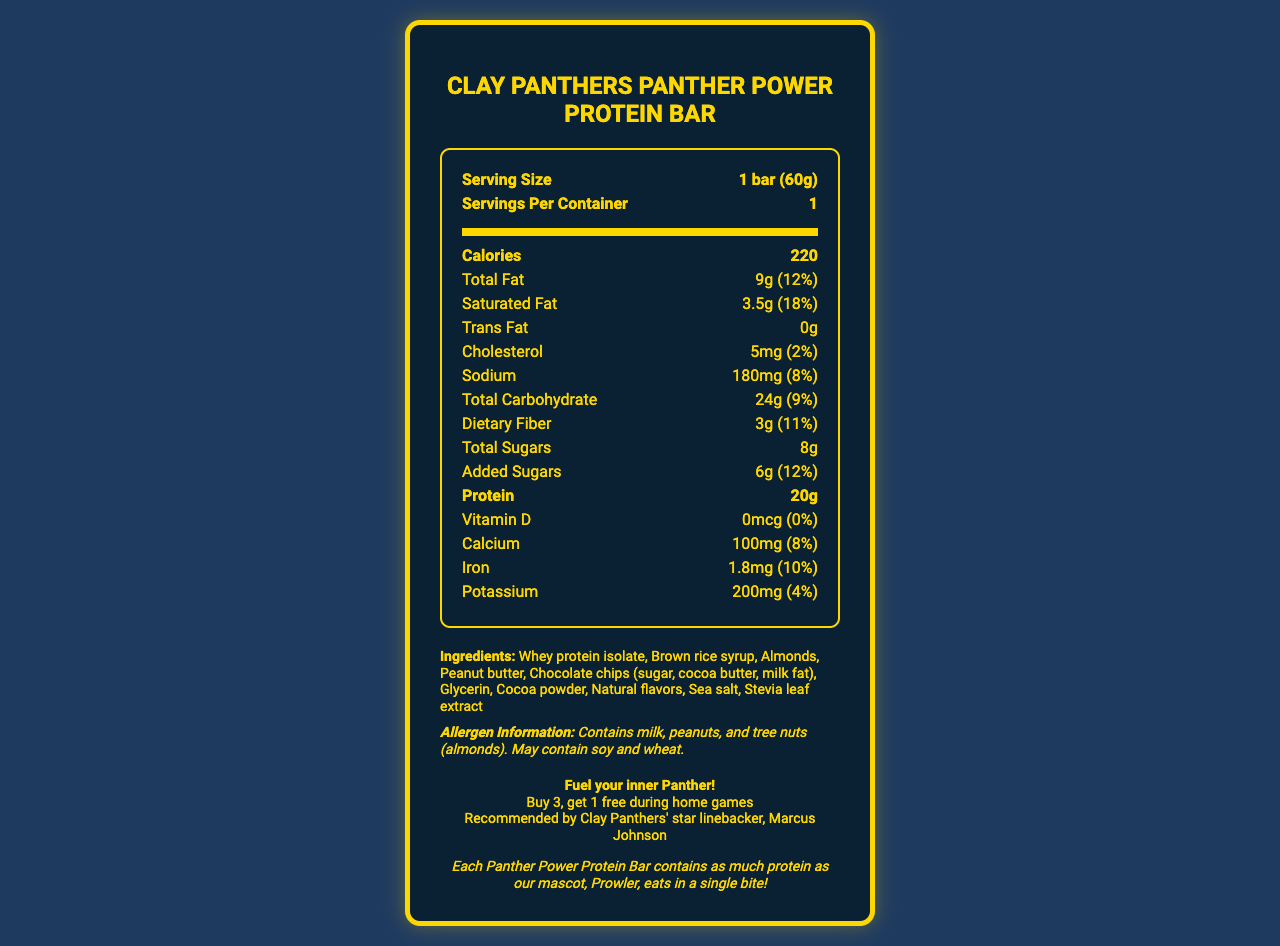what is the serving size of the Clay Panthers Panther Power Protein Bar? The serving size is clearly listed as "1 bar (60g)" in the document.
Answer: 1 bar (60g) how many calories are in one serving of the protein bar? The document lists the calories per serving as 220.
Answer: 220 how much total fat does the protein bar contain? The total fat content is written as "9g," which is also 12% of the daily value.
Answer: 9g how much protein is in each bar? Each bar contains 20 grams of protein according to the nutrition facts.
Answer: 20g how much calcium is in the Clay Panthers Panther Power Protein Bar? The document lists 100mg of calcium, which is 8% of the daily value.
Answer: 100mg what percentage of the daily value of saturated fat does the protein bar provide? The document specifies that the saturated fat content is 3.5g, which is 18% of the daily value.
Answer: 18% how many grams of total sugars are present in the protein bar? The document states that there are 8 grams of total sugars in the protein bar.
Answer: 8g what allergens are contained in the protein bar? The allergen information section specifies these allergens clearly.
Answer: Contains milk, peanuts, and tree nuts (almonds). May contain soy and wheat. which Clay Panthers player endorses the protein bar? A. Alex Smith B. Marcus Johnson C. David Brown The document states that the bar is recommended by Marcus Johnson, the star linebacker.
Answer: B what is the game day special offer mentioned in the document? A. Buy 2, get 1 free B. Buy 3, get 1 free C. 50% off on home games The game day special is listed as "Buy 3, get 1 free during home games."
Answer: B is the protein bar packaging sustainable? The document mentions that the wrapper is made from 100% recycled materials.
Answer: Yes summarize the main features of the Clay Panthers Panther Power Protein Bar as presented in the document. The summary condenses the main features such as nutrition details, endorsements, special offers, packaging sustainability, and allergen information mentioned in the document.
Answer: The Clay Panthers Panther Power Protein Bar is a stadium-exclusive product, endorsed by Marcus Johnson, and features 20 grams of protein per serving. It has 220 calories and includes ingredients such as whey protein isolate, peanut butter, and chocolate chips. The packaging is sustainable, and a game day special offers a "Buy 3, get 1 free" deal during home games. The bar also contains allergens like milk, peanuts, and almonds and has a fun fact that each bar contains as much protein as the mascot eats in a single bite. what is the mascot of the Clay Panthers mentioned in the document? The mascot is named Prowler, as mentioned in the fan fun fact section of the document.
Answer: Prowler does the protein bar contain any vitamin D? The document states that the vitamin D content is 0mcg, which is 0% of the daily value.
Answer: No what is the main ingredient in the protein bar? The first ingredient listed is usually the main ingredient, and in this case, it is whey protein isolate.
Answer: Whey protein isolate what is the carbohydrate content of the protein bar? I. 10g II. 24g III. 18g IV. 30g The document states that the total carbohydrate content is 24g, which is 9% of the daily value.
Answer: II how often is this product available for purchase outside the stadium? The document specifies it is a stadium-exclusive product, but it does not provide information on availability outside the stadium.
Answer: Not enough information 